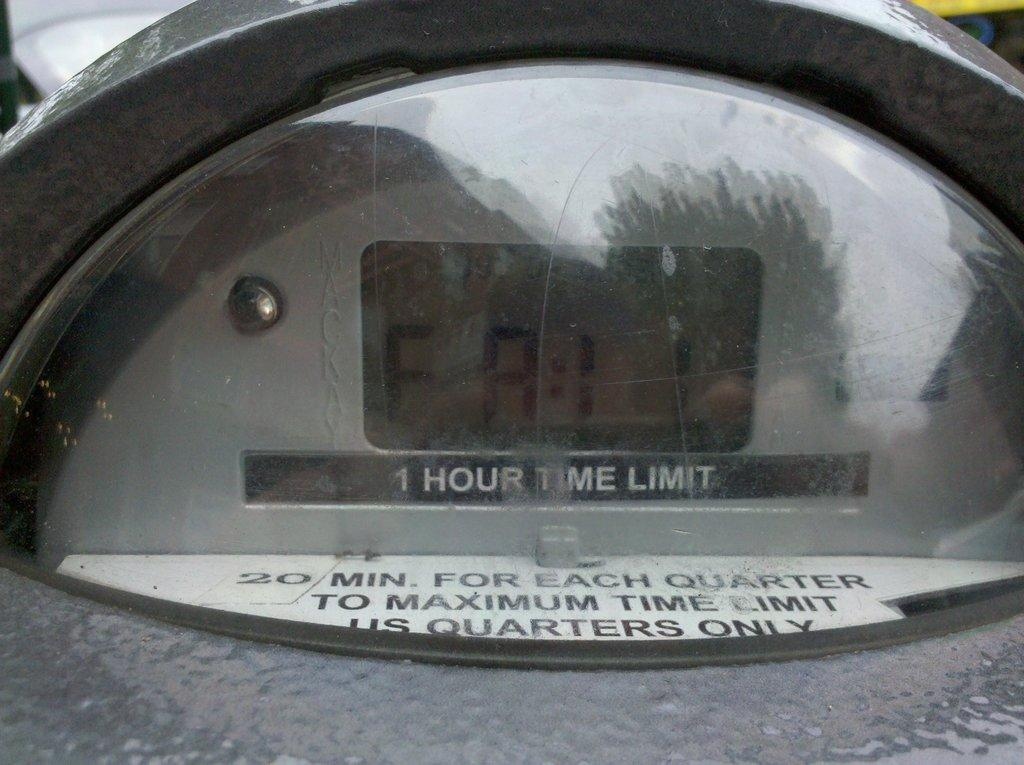<image>
Render a clear and concise summary of the photo. a glass item that has a 1 hour time limit 